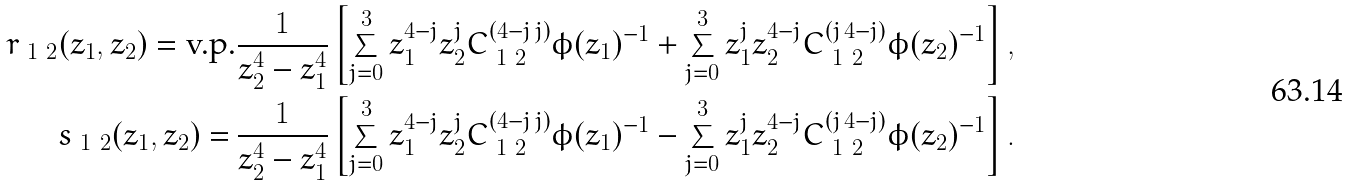<formula> <loc_0><loc_0><loc_500><loc_500>r _ { \ 1 \ 2 } ( z _ { 1 } , z _ { 2 } ) = \text {v.p.} & \frac { 1 } { z _ { 2 } ^ { 4 } - z _ { 1 } ^ { 4 } } \left [ \sum _ { j = 0 } ^ { 3 } z _ { 1 } ^ { 4 - j } z _ { 2 } ^ { j } C ^ { ( 4 - j \, j ) } _ { \ 1 \ 2 } \phi ( z _ { 1 } ) ^ { - 1 } + \sum _ { j = 0 } ^ { 3 } z _ { 1 } ^ { j } z _ { 2 } ^ { 4 - j } C ^ { ( j \, 4 - j ) } _ { \ 1 \ 2 } \phi ( z _ { 2 } ) ^ { - 1 } \right ] , \\ s _ { \ 1 \ 2 } ( z _ { 1 } , z _ { 2 } ) = \, & \frac { 1 } { z _ { 2 } ^ { 4 } - z _ { 1 } ^ { 4 } } \left [ \sum _ { j = 0 } ^ { 3 } z _ { 1 } ^ { 4 - j } z _ { 2 } ^ { j } C ^ { ( 4 - j \, j ) } _ { \ 1 \ 2 } \phi ( z _ { 1 } ) ^ { - 1 } - \sum _ { j = 0 } ^ { 3 } z _ { 1 } ^ { j } z _ { 2 } ^ { 4 - j } C ^ { ( j \, 4 - j ) } _ { \ 1 \ 2 } \phi ( z _ { 2 } ) ^ { - 1 } \right ] .</formula> 